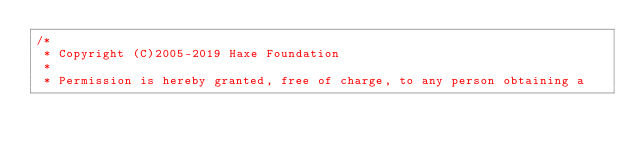<code> <loc_0><loc_0><loc_500><loc_500><_Haxe_>/*
 * Copyright (C)2005-2019 Haxe Foundation
 *
 * Permission is hereby granted, free of charge, to any person obtaining a</code> 